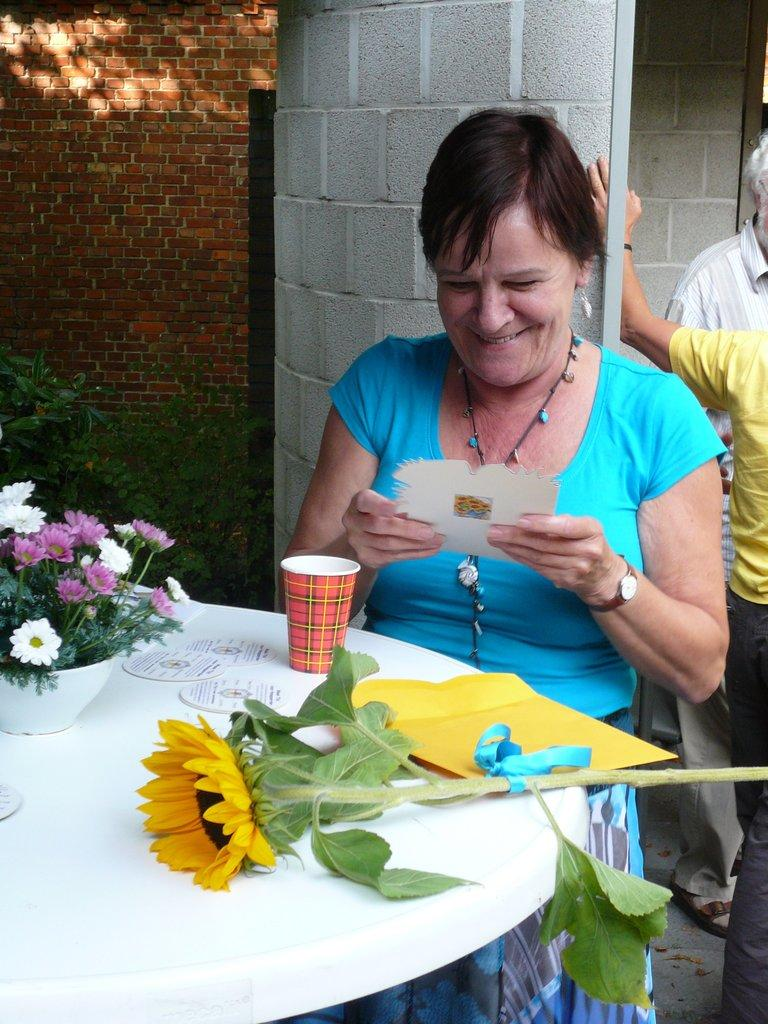Who or what is the main subject in the image? There is a person in the image. Can you describe the person's attire? The person is wearing clothes. What is the person's position in relation to the table? The person is standing in front of a table. What items can be seen on the table? The table contains flowers and a cup. What is the person holding in her hands? The person is holding a card with her hands. What type of clover is growing on the table in the image? There is no clover present on the table in the image; it contains flowers and a cup. What color is the gold crib in the image? There is no gold crib present in the image. 